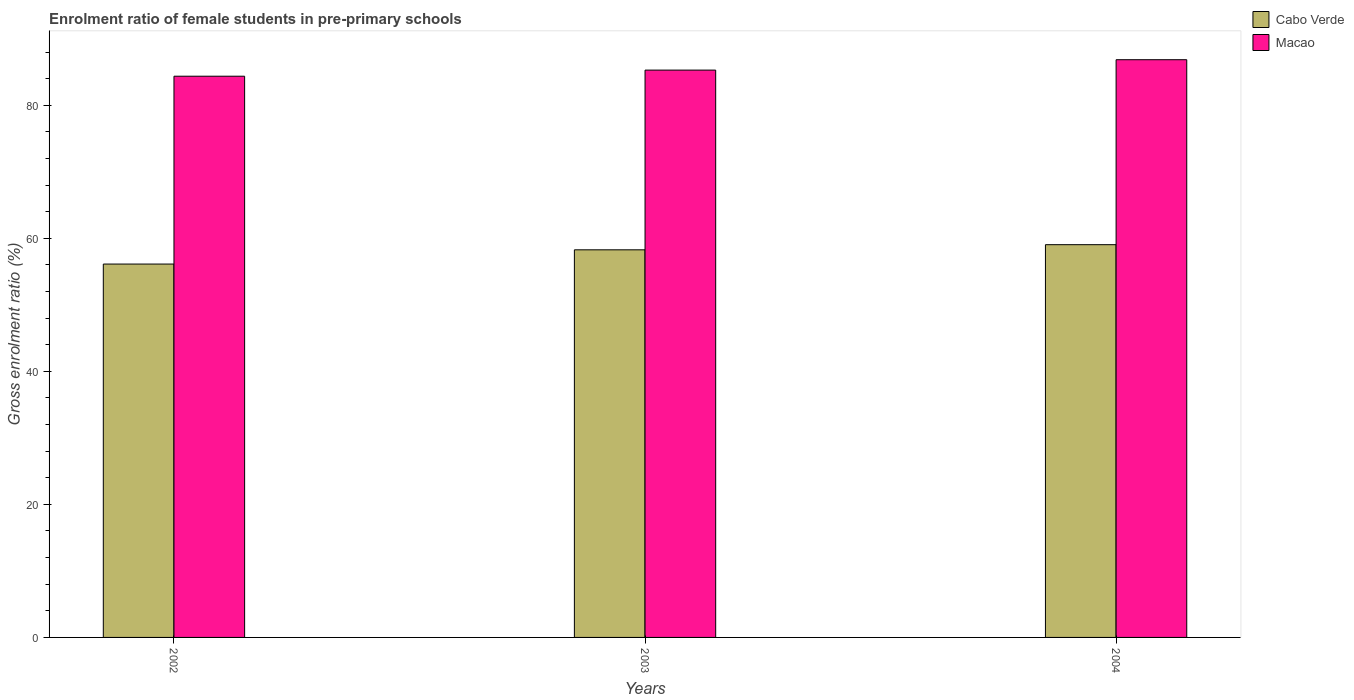How many groups of bars are there?
Make the answer very short. 3. How many bars are there on the 3rd tick from the left?
Your answer should be compact. 2. What is the label of the 2nd group of bars from the left?
Your response must be concise. 2003. What is the enrolment ratio of female students in pre-primary schools in Cabo Verde in 2003?
Your response must be concise. 58.27. Across all years, what is the maximum enrolment ratio of female students in pre-primary schools in Cabo Verde?
Provide a succinct answer. 59.04. Across all years, what is the minimum enrolment ratio of female students in pre-primary schools in Cabo Verde?
Keep it short and to the point. 56.13. In which year was the enrolment ratio of female students in pre-primary schools in Cabo Verde minimum?
Provide a short and direct response. 2002. What is the total enrolment ratio of female students in pre-primary schools in Cabo Verde in the graph?
Keep it short and to the point. 173.44. What is the difference between the enrolment ratio of female students in pre-primary schools in Macao in 2003 and that in 2004?
Offer a terse response. -1.56. What is the difference between the enrolment ratio of female students in pre-primary schools in Macao in 2003 and the enrolment ratio of female students in pre-primary schools in Cabo Verde in 2004?
Give a very brief answer. 26.24. What is the average enrolment ratio of female students in pre-primary schools in Macao per year?
Your answer should be compact. 85.5. In the year 2003, what is the difference between the enrolment ratio of female students in pre-primary schools in Macao and enrolment ratio of female students in pre-primary schools in Cabo Verde?
Offer a very short reply. 27.02. In how many years, is the enrolment ratio of female students in pre-primary schools in Cabo Verde greater than 80 %?
Make the answer very short. 0. What is the ratio of the enrolment ratio of female students in pre-primary schools in Cabo Verde in 2002 to that in 2003?
Keep it short and to the point. 0.96. What is the difference between the highest and the second highest enrolment ratio of female students in pre-primary schools in Macao?
Keep it short and to the point. 1.56. What is the difference between the highest and the lowest enrolment ratio of female students in pre-primary schools in Macao?
Provide a short and direct response. 2.48. In how many years, is the enrolment ratio of female students in pre-primary schools in Macao greater than the average enrolment ratio of female students in pre-primary schools in Macao taken over all years?
Offer a very short reply. 1. What does the 2nd bar from the left in 2003 represents?
Your response must be concise. Macao. What does the 2nd bar from the right in 2004 represents?
Make the answer very short. Cabo Verde. How many bars are there?
Ensure brevity in your answer.  6. How many years are there in the graph?
Ensure brevity in your answer.  3. Does the graph contain any zero values?
Offer a very short reply. No. Where does the legend appear in the graph?
Keep it short and to the point. Top right. How are the legend labels stacked?
Provide a succinct answer. Vertical. What is the title of the graph?
Make the answer very short. Enrolment ratio of female students in pre-primary schools. Does "Rwanda" appear as one of the legend labels in the graph?
Give a very brief answer. No. What is the Gross enrolment ratio (%) in Cabo Verde in 2002?
Provide a short and direct response. 56.13. What is the Gross enrolment ratio (%) of Macao in 2002?
Your answer should be compact. 84.37. What is the Gross enrolment ratio (%) in Cabo Verde in 2003?
Your response must be concise. 58.27. What is the Gross enrolment ratio (%) in Macao in 2003?
Provide a succinct answer. 85.29. What is the Gross enrolment ratio (%) of Cabo Verde in 2004?
Ensure brevity in your answer.  59.04. What is the Gross enrolment ratio (%) in Macao in 2004?
Provide a short and direct response. 86.85. Across all years, what is the maximum Gross enrolment ratio (%) in Cabo Verde?
Your response must be concise. 59.04. Across all years, what is the maximum Gross enrolment ratio (%) in Macao?
Offer a very short reply. 86.85. Across all years, what is the minimum Gross enrolment ratio (%) in Cabo Verde?
Ensure brevity in your answer.  56.13. Across all years, what is the minimum Gross enrolment ratio (%) of Macao?
Ensure brevity in your answer.  84.37. What is the total Gross enrolment ratio (%) in Cabo Verde in the graph?
Make the answer very short. 173.44. What is the total Gross enrolment ratio (%) in Macao in the graph?
Your answer should be very brief. 256.5. What is the difference between the Gross enrolment ratio (%) of Cabo Verde in 2002 and that in 2003?
Your answer should be compact. -2.14. What is the difference between the Gross enrolment ratio (%) in Macao in 2002 and that in 2003?
Your response must be concise. -0.92. What is the difference between the Gross enrolment ratio (%) in Cabo Verde in 2002 and that in 2004?
Provide a short and direct response. -2.91. What is the difference between the Gross enrolment ratio (%) in Macao in 2002 and that in 2004?
Your answer should be very brief. -2.48. What is the difference between the Gross enrolment ratio (%) in Cabo Verde in 2003 and that in 2004?
Your answer should be very brief. -0.77. What is the difference between the Gross enrolment ratio (%) in Macao in 2003 and that in 2004?
Keep it short and to the point. -1.56. What is the difference between the Gross enrolment ratio (%) in Cabo Verde in 2002 and the Gross enrolment ratio (%) in Macao in 2003?
Offer a very short reply. -29.16. What is the difference between the Gross enrolment ratio (%) in Cabo Verde in 2002 and the Gross enrolment ratio (%) in Macao in 2004?
Ensure brevity in your answer.  -30.72. What is the difference between the Gross enrolment ratio (%) in Cabo Verde in 2003 and the Gross enrolment ratio (%) in Macao in 2004?
Your answer should be very brief. -28.58. What is the average Gross enrolment ratio (%) of Cabo Verde per year?
Ensure brevity in your answer.  57.81. What is the average Gross enrolment ratio (%) of Macao per year?
Your response must be concise. 85.5. In the year 2002, what is the difference between the Gross enrolment ratio (%) of Cabo Verde and Gross enrolment ratio (%) of Macao?
Provide a succinct answer. -28.24. In the year 2003, what is the difference between the Gross enrolment ratio (%) of Cabo Verde and Gross enrolment ratio (%) of Macao?
Make the answer very short. -27.02. In the year 2004, what is the difference between the Gross enrolment ratio (%) of Cabo Verde and Gross enrolment ratio (%) of Macao?
Offer a very short reply. -27.81. What is the ratio of the Gross enrolment ratio (%) of Cabo Verde in 2002 to that in 2003?
Ensure brevity in your answer.  0.96. What is the ratio of the Gross enrolment ratio (%) of Macao in 2002 to that in 2003?
Your answer should be very brief. 0.99. What is the ratio of the Gross enrolment ratio (%) of Cabo Verde in 2002 to that in 2004?
Your answer should be very brief. 0.95. What is the ratio of the Gross enrolment ratio (%) in Macao in 2002 to that in 2004?
Provide a short and direct response. 0.97. What is the ratio of the Gross enrolment ratio (%) in Cabo Verde in 2003 to that in 2004?
Your answer should be compact. 0.99. What is the ratio of the Gross enrolment ratio (%) of Macao in 2003 to that in 2004?
Offer a very short reply. 0.98. What is the difference between the highest and the second highest Gross enrolment ratio (%) in Cabo Verde?
Your response must be concise. 0.77. What is the difference between the highest and the second highest Gross enrolment ratio (%) in Macao?
Offer a very short reply. 1.56. What is the difference between the highest and the lowest Gross enrolment ratio (%) in Cabo Verde?
Offer a very short reply. 2.91. What is the difference between the highest and the lowest Gross enrolment ratio (%) of Macao?
Make the answer very short. 2.48. 